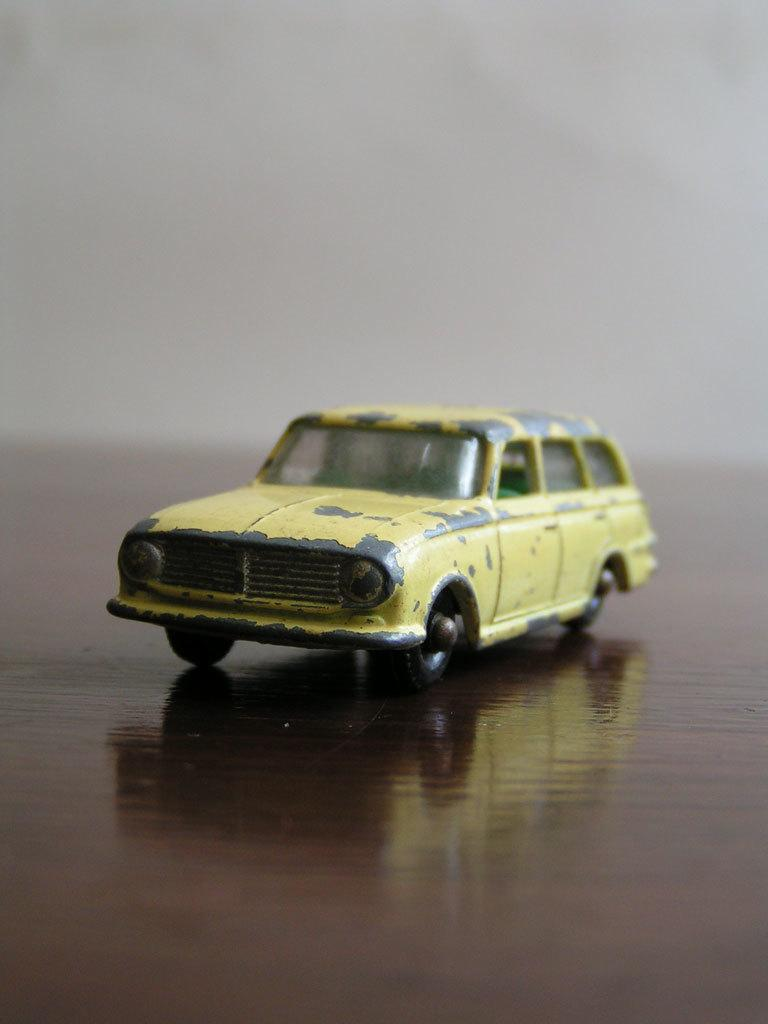What is the main subject of the image? The main subject of the image is a toy car. Can you describe the background of the toy car? The background of the toy car is blurred. What is the level of wealth displayed by the goat in the image? There is no goat present in the image, so it is not possible to determine the level of wealth displayed by a goat. 